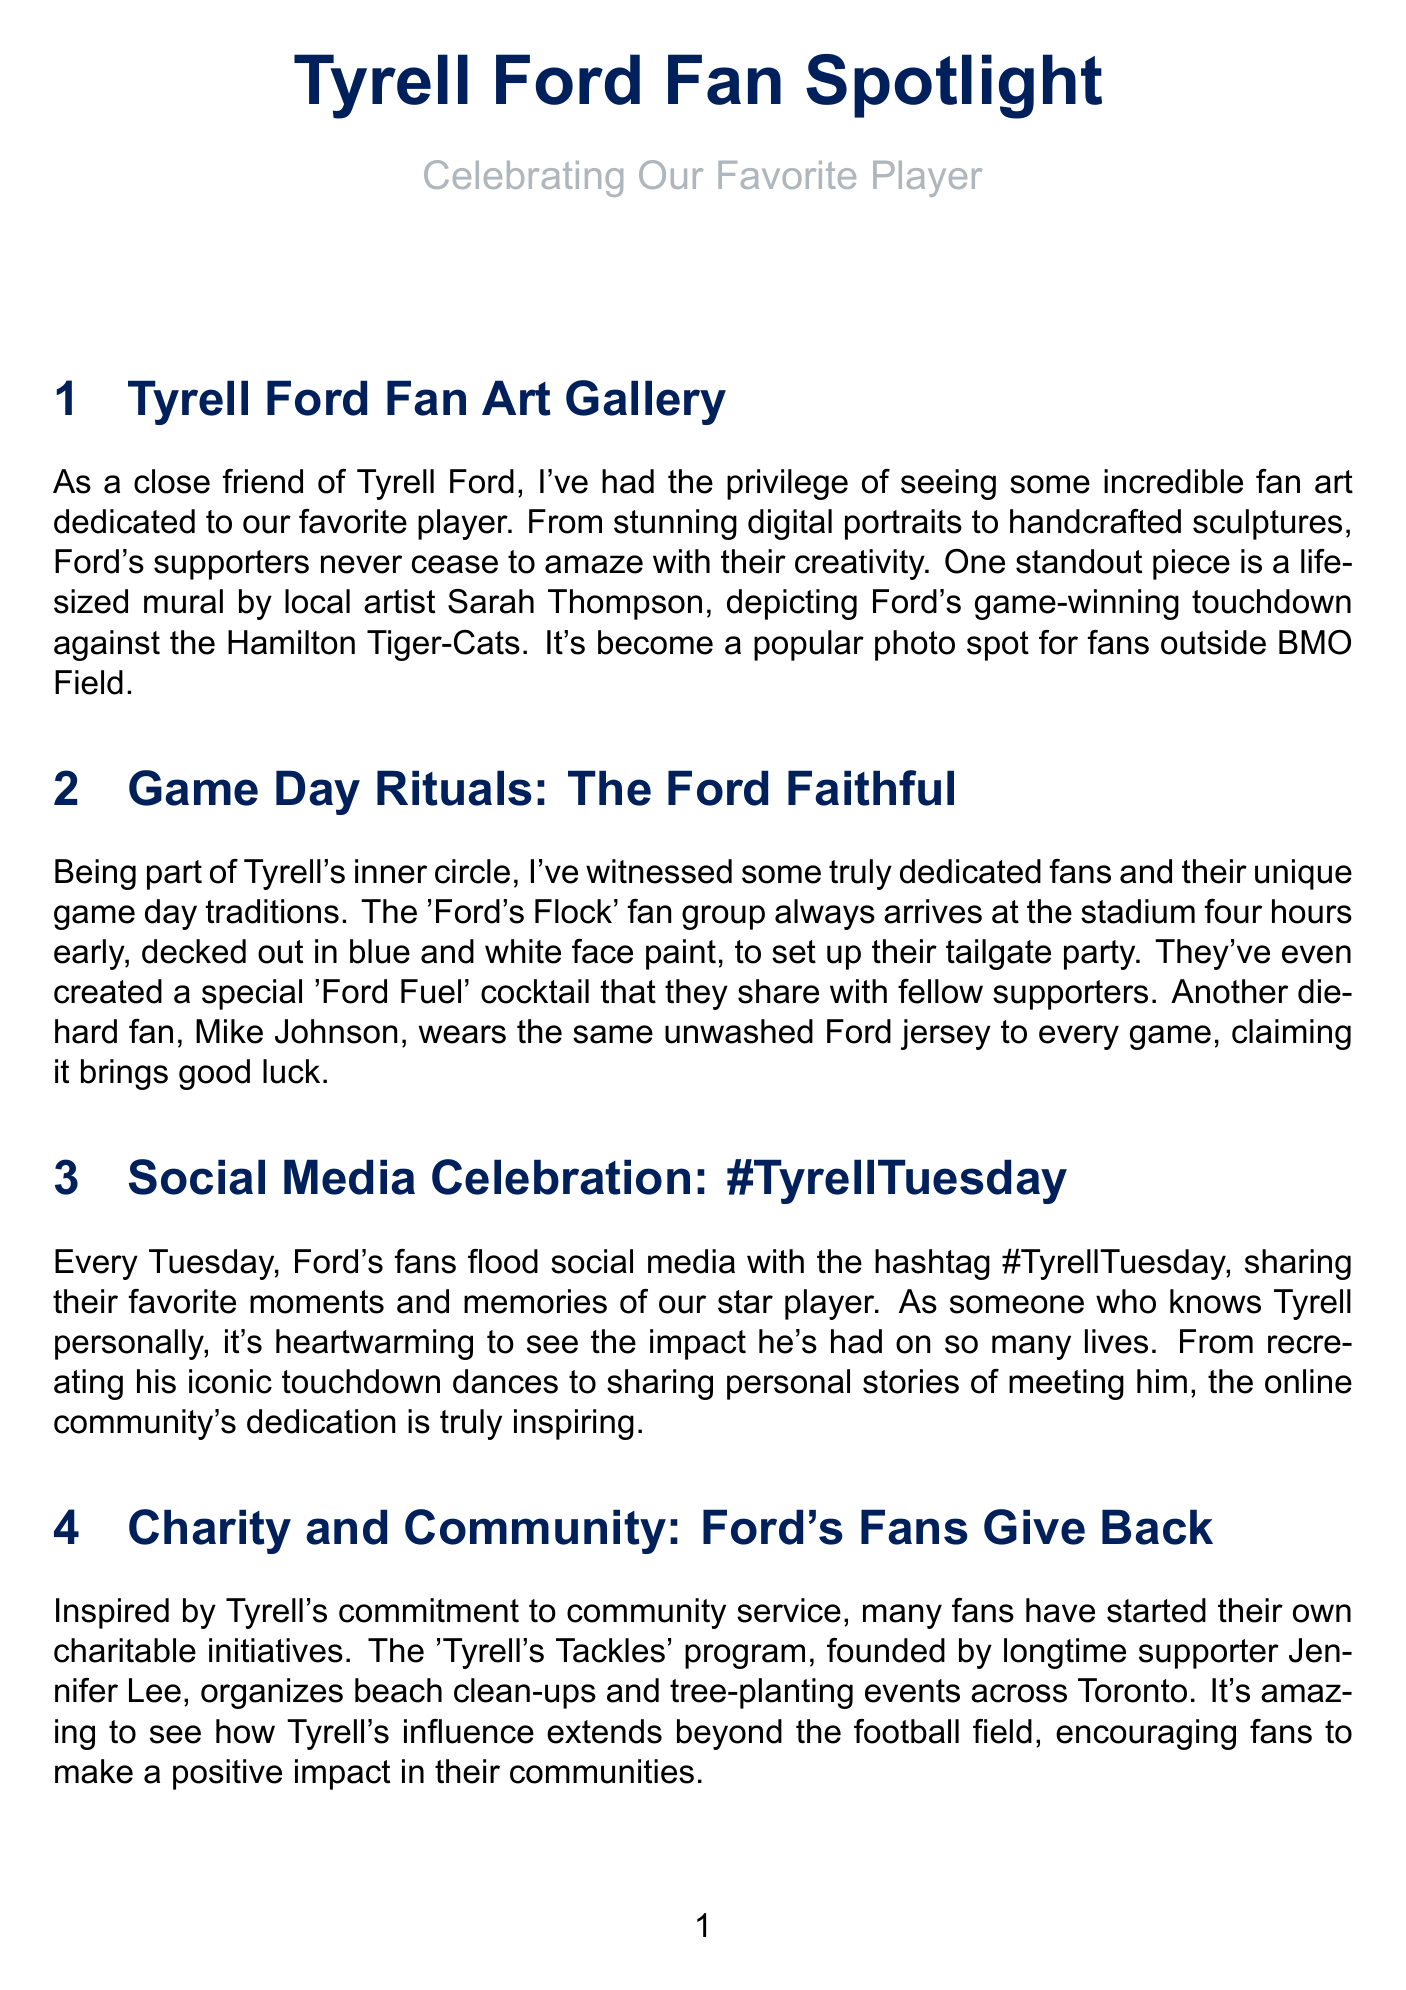What is the title of the fan art gallery section? The title of the fan art gallery section is provided in the document's header and is "Tyrell Ford Fan Art Gallery."
Answer: Tyrell Ford Fan Art Gallery Who created the life-sized mural of Tyrell Ford? The mural was created by local artist Sarah Thompson, as mentioned in the fan art section.
Answer: Sarah Thompson What is the name of the fan group that arrives early on game days? The fan group is called "Ford's Flock," which is detailed in the game day rituals section.
Answer: Ford's Flock What special cocktail do the fans share during their tailgate party? The special cocktail created by fans is called "Ford Fuel," which is mentioned in the game day rituals section.
Answer: Ford Fuel What hashtag do fans use on social media every Tuesday? The hashtag that fans use is "#TyrellTuesday," as highlighted in the social media celebration section.
Answer: #TyrellTuesday Which program did Jennifer Lee found? The program founded by Jennifer Lee is called "Tyrell's Tackles," referenced in the charity and community section.
Answer: Tyrell's Tackles What event features a look-alike contest for Tyrell Ford? The event that features a look-alike contest is the Canadian National Exhibition, as described in the look-alike contest section.
Answer: Canadian National Exhibition How did last year's look-alike contest winner impress reporters? The winner, Carlos Ramirez, impressed reporters with his spot-on impersonation, as stated in the look-alike contest section.
Answer: Spot-on impersonation 